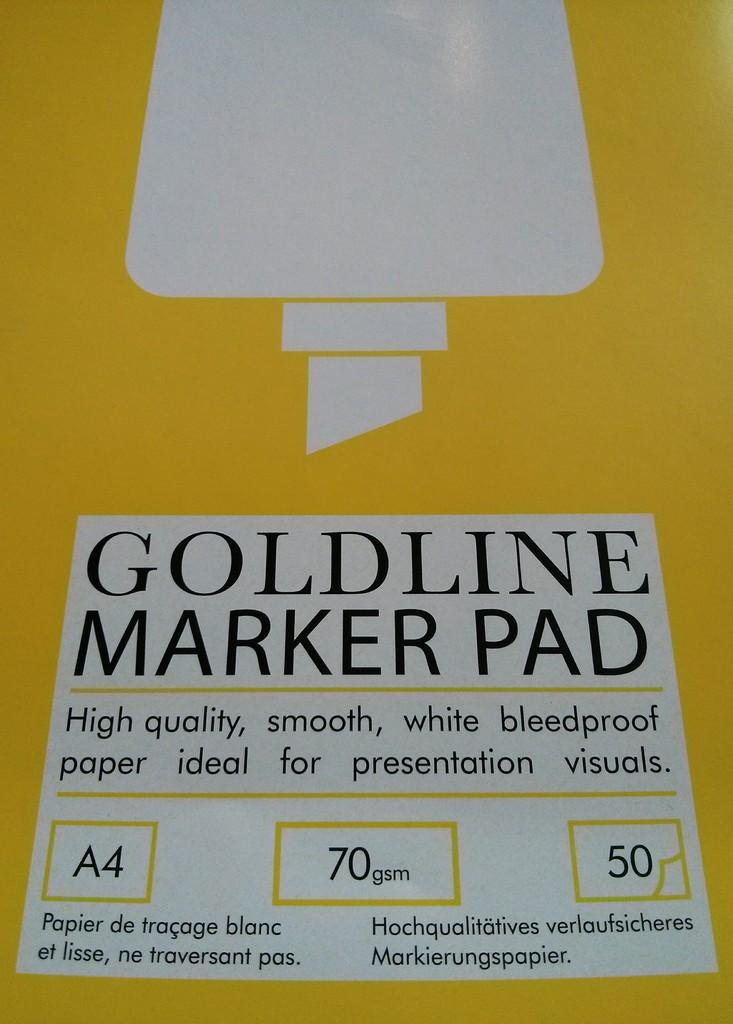<image>
Create a compact narrative representing the image presented. Closeup of Goldline Marker pad that includes bleedproof paper. 